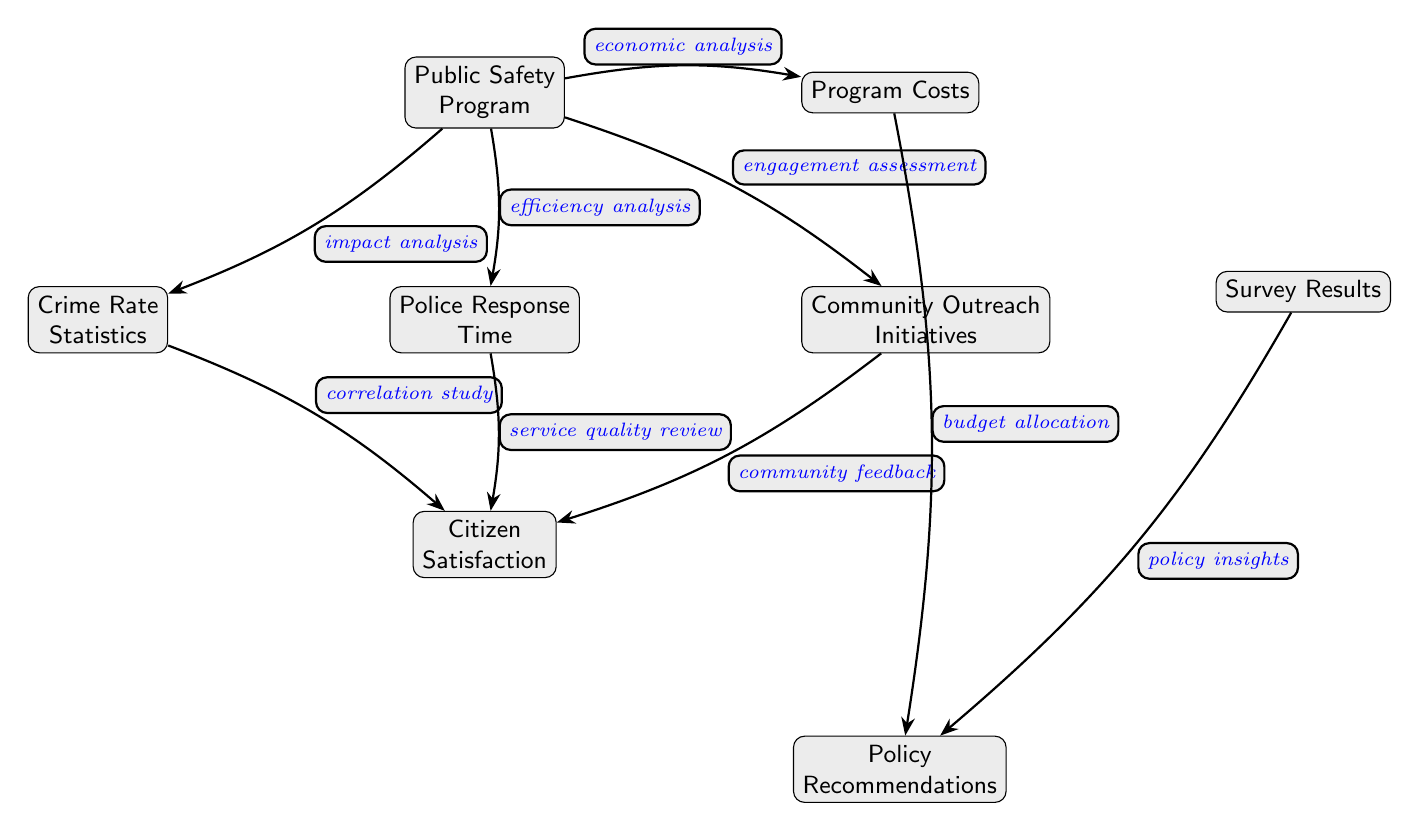What is the main node in the diagram? The central node labeled as "Public Safety Program" is the main focus of the diagram, indicating its significance in the analysis of public safety.
Answer: Public Safety Program How many nodes are connected to the main node? There are five nodes directly connected to the "Public Safety Program," indicating aspects that contribute to or derive from it.
Answer: 5 What type of analysis connects the "Public Safety Program" to "Crime Rate Statistics"? The diagram indicates that the connection is described as "impact analysis," which signifies that the impact of the public safety program is being analyzed in relation to crime rates.
Answer: impact analysis Which node evaluates the relationship between "Police Response Time" and "Citizen Satisfaction"? The "Citizen Satisfaction" node receives input from "Police Response Time," indicating the quality of police service directly influences citizen satisfaction.
Answer: Citizen Satisfaction What kind of analysis is performed between "Community Outreach Initiatives" and "Citizen Satisfaction"? The connection is indicated as "community feedback," which implies that feedback from the community is used to gauge citizen satisfaction based on outreach initiatives.
Answer: community feedback What is the edge type connecting "Program Costs" to "Policy Recommendations"? The edge denotes "budget allocation," showing how program costs are factored into policy recommendations for future public safety planning.
Answer: budget allocation Which two nodes represent feedback mechanisms in the analysis? "Survey Results" and "Community Outreach Initiatives" both gather feedback from citizens, affecting the overall assessment of the public safety program's effectiveness.
Answer: Survey Results, Community Outreach Initiatives What is the relationship indicated between "Crime Rate Statistics" and "Citizen Satisfaction"? "Crime Rate Statistics" is linked to "Citizen Satisfaction" through a "correlation study," suggesting that changes in crime rates could correlate with citizen perceptions of safety.
Answer: correlation study What does the edge labeled "efficiency analysis" connect? This edge connects the "Public Safety Program" to "Police Response Time," focusing on how efficiently police resources are being utilized.
Answer: Police Response Time 